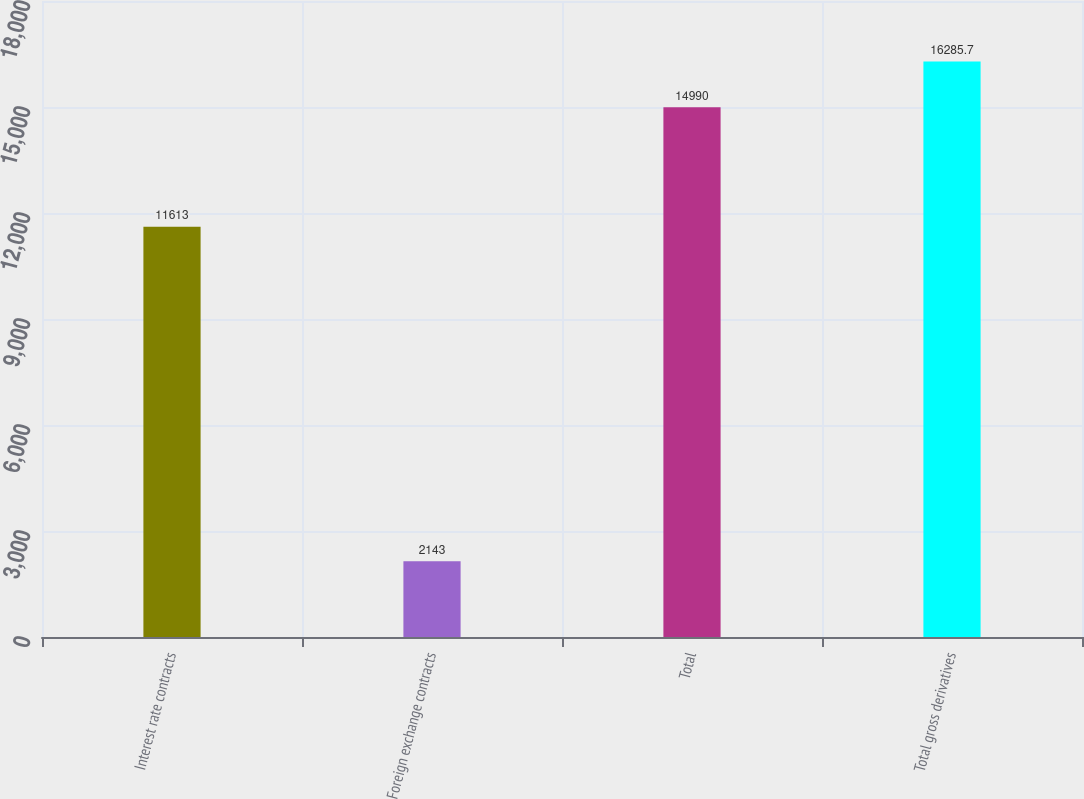<chart> <loc_0><loc_0><loc_500><loc_500><bar_chart><fcel>Interest rate contracts<fcel>Foreign exchange contracts<fcel>Total<fcel>Total gross derivatives<nl><fcel>11613<fcel>2143<fcel>14990<fcel>16285.7<nl></chart> 